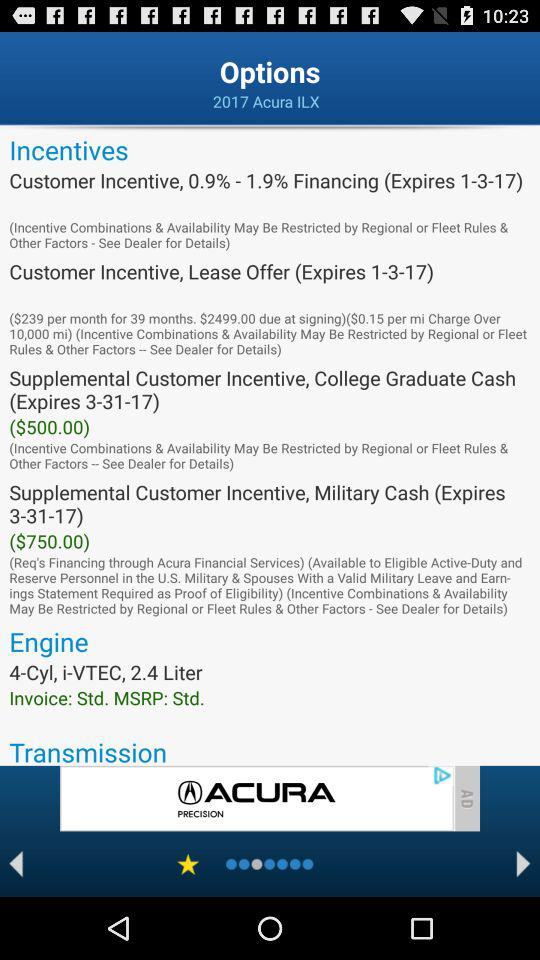How many incentives are available on this vehicle?
Answer the question using a single word or phrase. 4 